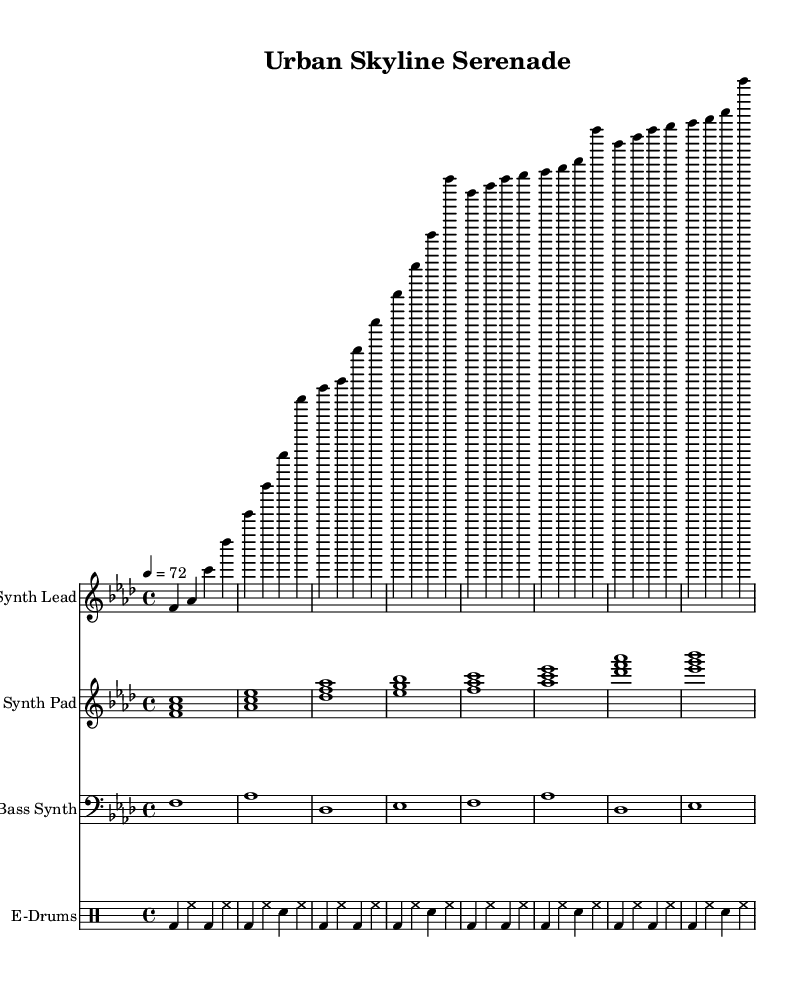What is the key signature of this music? The key signature indicated in the sheet music is F minor, which has four flats (B, E, A, D).
Answer: F minor What is the time signature of this music? The time signature shows a "4/4" time, which means there are four beats in each measure, and the quarter note gets one beat.
Answer: 4/4 What is the tempo marking for the piece? The tempo marking states "4 = 72", meaning that there are 72 beats per minute, with a quarter note receiving one beat.
Answer: 72 How many measures are in the synth lead part? Counting the measures in the synth lead part, there are eight measures shown in total for this section of the music.
Answer: 8 What is the instrument name for the first staff? The first staff is labeled as "Synth Lead", indicating that the music should be played on a synthesizer that leads the piece.
Answer: Synth Lead How many different instrumental parts are present in the score? By looking at the score, there are four distinct instrumental parts: "Synth Lead", "Synth Pad", "Bass Synth", and "E-Drums".
Answer: 4 What type of rhythm pattern is used for the drums? The drum pattern consists of bass drum and hi-hat, which are commonly used in electronic music for a steady beat and groove.
Answer: E-Drums 